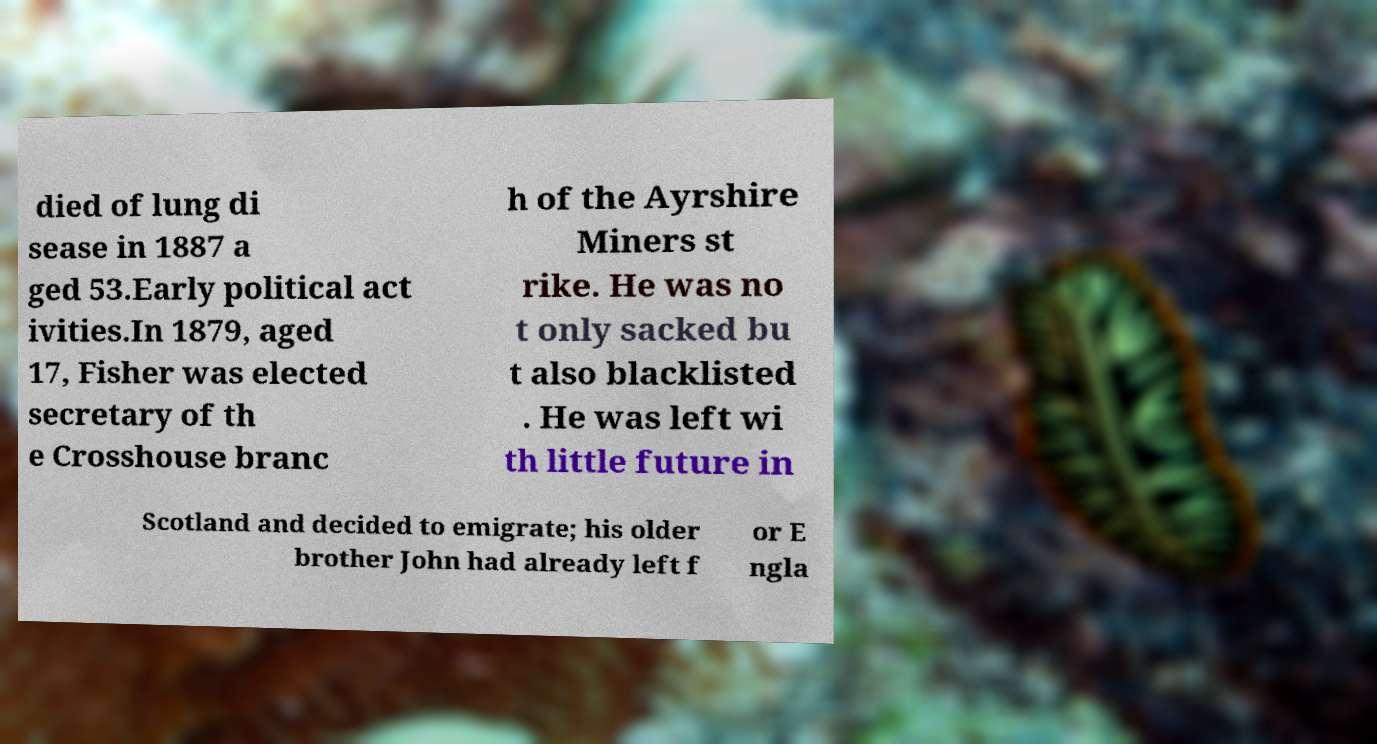Can you accurately transcribe the text from the provided image for me? died of lung di sease in 1887 a ged 53.Early political act ivities.In 1879, aged 17, Fisher was elected secretary of th e Crosshouse branc h of the Ayrshire Miners st rike. He was no t only sacked bu t also blacklisted . He was left wi th little future in Scotland and decided to emigrate; his older brother John had already left f or E ngla 